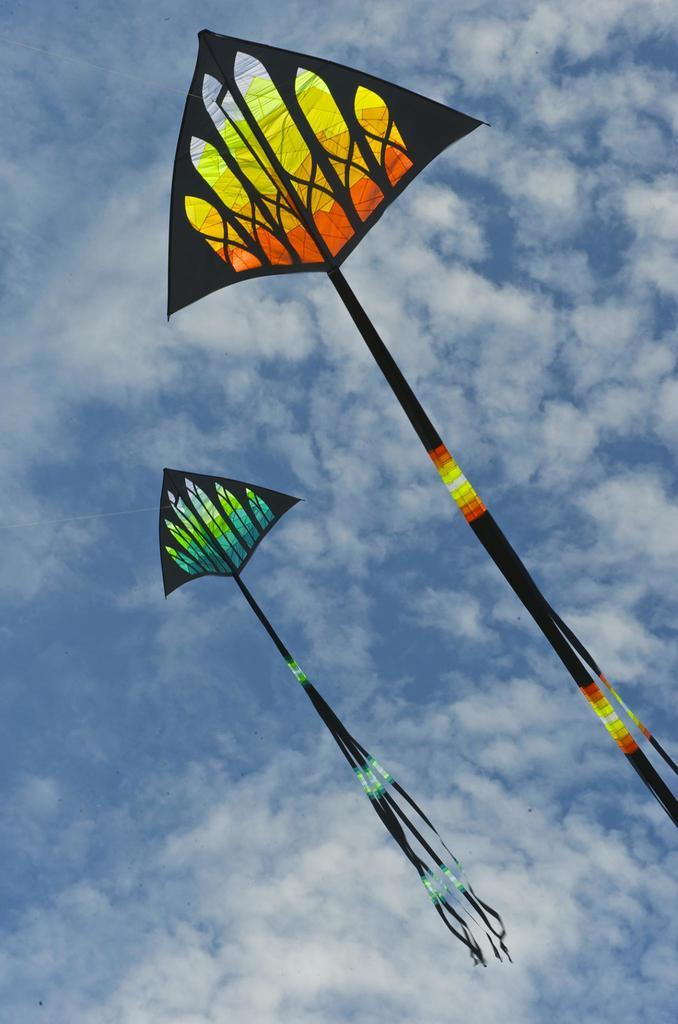What objects are in the air in the image? There are two kites in the image, and they are flying in the air. Can you describe the position of the kites in the image? The kites are in the air, and they are flying. What is the primary activity depicted in the image? The primary activity depicted in the image is kite flying. What type of lumber is being used to support the kites in the image? There is no lumber present in the image; the kites are flying in the air without any visible support. 